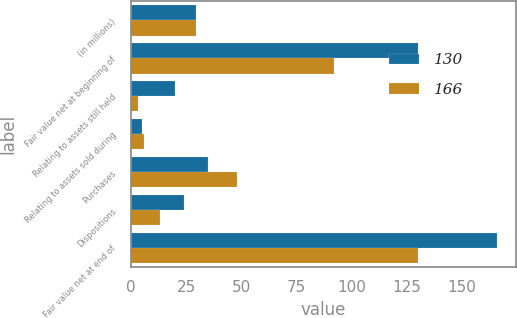Convert chart to OTSL. <chart><loc_0><loc_0><loc_500><loc_500><stacked_bar_chart><ecel><fcel>(in millions)<fcel>Fair value net at beginning of<fcel>Relating to assets still held<fcel>Relating to assets sold during<fcel>Purchases<fcel>Dispositions<fcel>Fair value net at end of<nl><fcel>130<fcel>29.5<fcel>130<fcel>20<fcel>5<fcel>35<fcel>24<fcel>166<nl><fcel>166<fcel>29.5<fcel>92<fcel>3<fcel>6<fcel>48<fcel>13<fcel>130<nl></chart> 